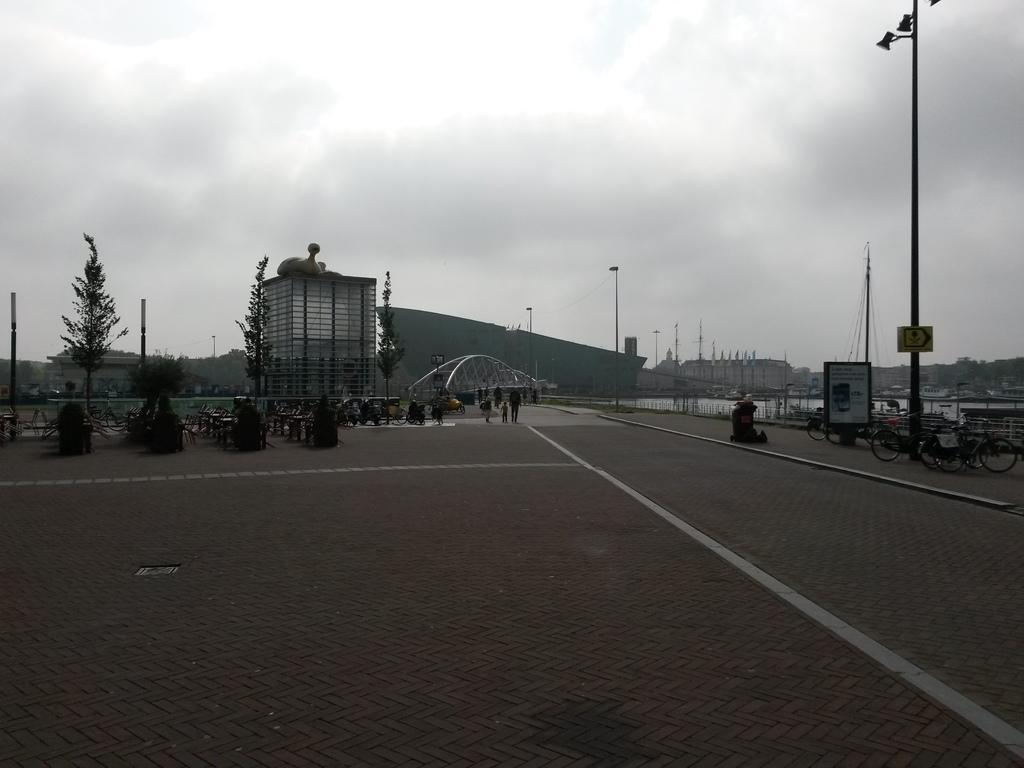How would you summarize this image in a sentence or two? In this image there are a few cycles parked on the pavement, beside the cycles there is a lamp post, on the other side of the pavement there are few people walking. In the background of the image there are trees and buildings. 